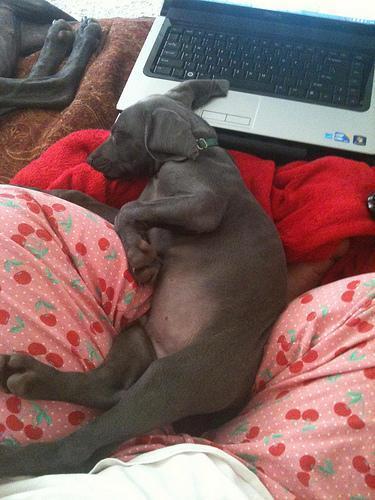How many dogs are in the photo?
Give a very brief answer. 2. 